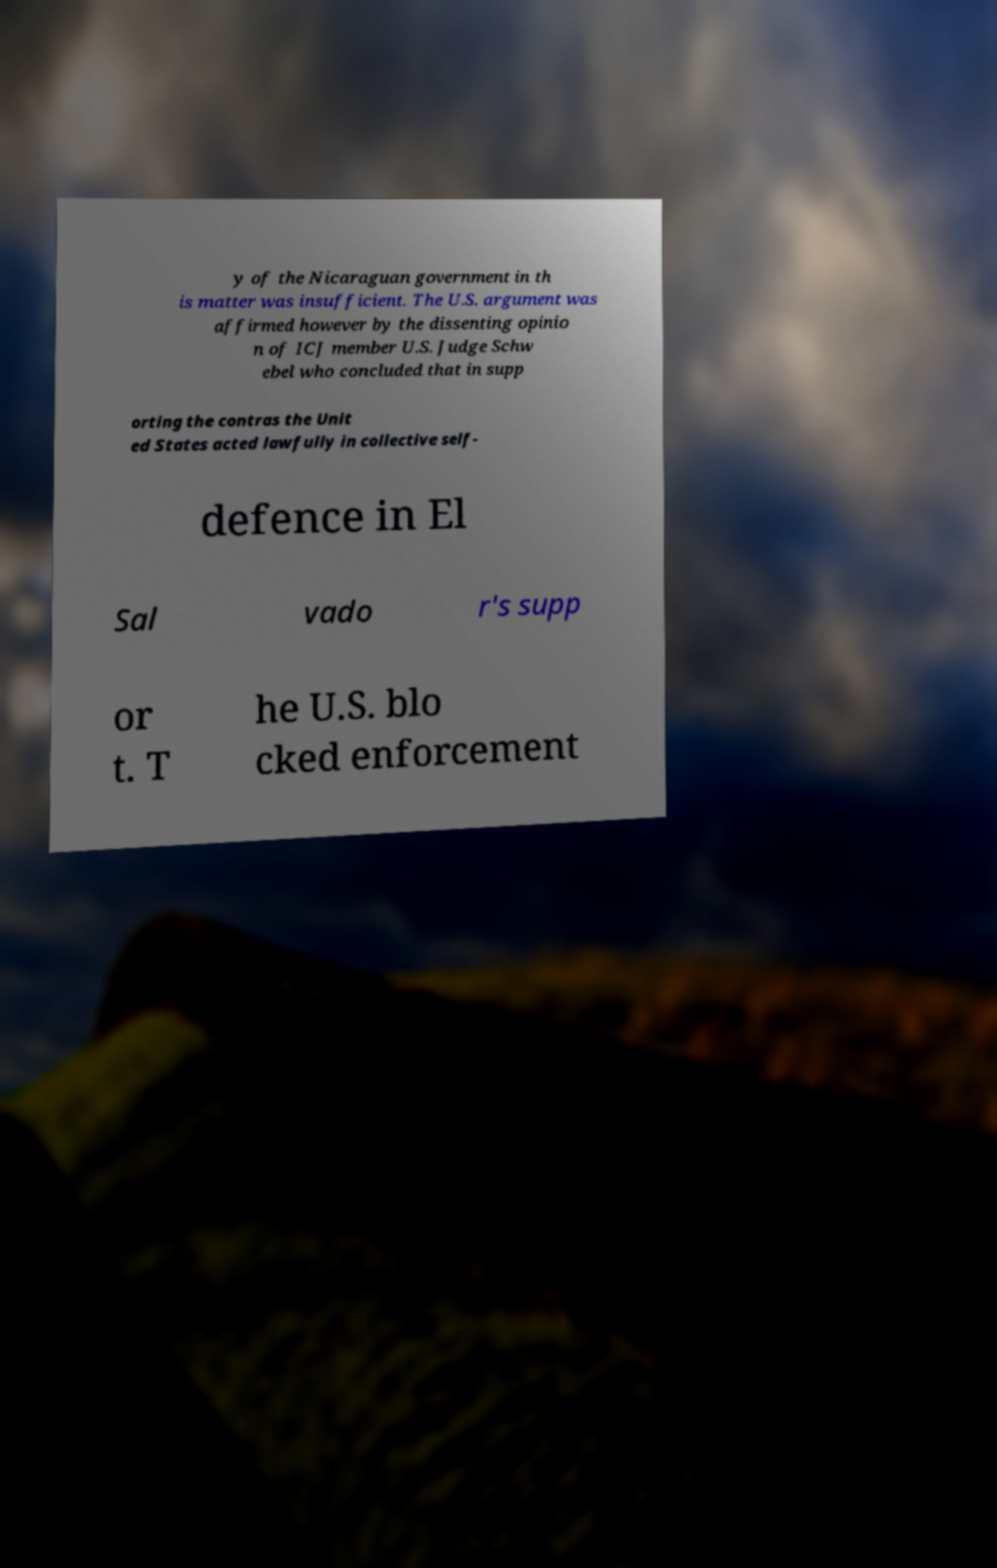Can you accurately transcribe the text from the provided image for me? y of the Nicaraguan government in th is matter was insufficient. The U.S. argument was affirmed however by the dissenting opinio n of ICJ member U.S. Judge Schw ebel who concluded that in supp orting the contras the Unit ed States acted lawfully in collective self- defence in El Sal vado r's supp or t. T he U.S. blo cked enforcement 